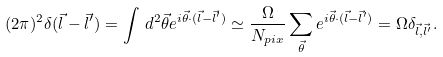<formula> <loc_0><loc_0><loc_500><loc_500>( 2 \pi ) ^ { 2 } \delta ( \vec { l } - \vec { l } ^ { \prime } ) = \int \, d ^ { 2 } \vec { \theta } e ^ { i \vec { \theta } \cdot ( \vec { l } - \vec { l } ^ { \prime } ) } \simeq \frac { \Omega } { N _ { p i x } } \sum _ { \vec { \theta } } e ^ { i \vec { \theta } \cdot ( \vec { l } - \vec { l } ^ { \prime } ) } = \Omega \delta _ { \vec { l } , \vec { l } ^ { \prime } } .</formula> 